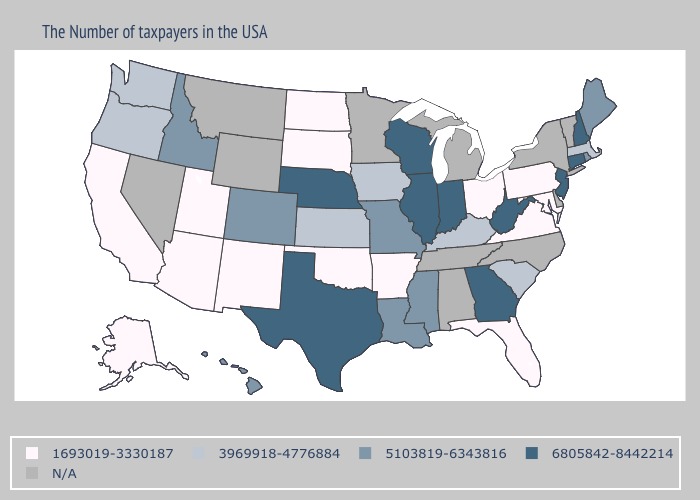What is the lowest value in the Northeast?
Give a very brief answer. 1693019-3330187. Name the states that have a value in the range N/A?
Keep it brief. Vermont, New York, Delaware, North Carolina, Michigan, Alabama, Tennessee, Minnesota, Wyoming, Montana, Nevada. Which states hav the highest value in the South?
Short answer required. West Virginia, Georgia, Texas. What is the highest value in the USA?
Keep it brief. 6805842-8442214. What is the value of New Mexico?
Write a very short answer. 1693019-3330187. Name the states that have a value in the range 6805842-8442214?
Write a very short answer. New Hampshire, Connecticut, New Jersey, West Virginia, Georgia, Indiana, Wisconsin, Illinois, Nebraska, Texas. Which states have the lowest value in the West?
Concise answer only. New Mexico, Utah, Arizona, California, Alaska. Name the states that have a value in the range 6805842-8442214?
Be succinct. New Hampshire, Connecticut, New Jersey, West Virginia, Georgia, Indiana, Wisconsin, Illinois, Nebraska, Texas. Which states hav the highest value in the Northeast?
Answer briefly. New Hampshire, Connecticut, New Jersey. Which states hav the highest value in the South?
Be succinct. West Virginia, Georgia, Texas. Name the states that have a value in the range 5103819-6343816?
Write a very short answer. Maine, Rhode Island, Mississippi, Louisiana, Missouri, Colorado, Idaho, Hawaii. What is the value of New Jersey?
Keep it brief. 6805842-8442214. Among the states that border Ohio , which have the lowest value?
Give a very brief answer. Pennsylvania. Name the states that have a value in the range 5103819-6343816?
Short answer required. Maine, Rhode Island, Mississippi, Louisiana, Missouri, Colorado, Idaho, Hawaii. What is the lowest value in states that border New Mexico?
Write a very short answer. 1693019-3330187. 